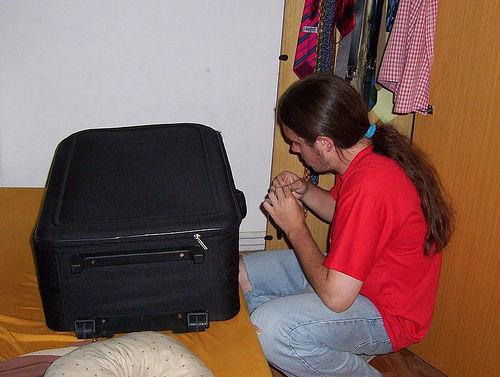Identify the hairstyle of the person in the image. The man has a long ponytail held together with a blue hair band. What is the color of the man's shirt and what type of shirt is it? The man is wearing a red short sleeve shirt. What is the color and type of the object on the man's head? There is a light blue hair band around the man's ponytail. What is the man doing in the image and describe his overall appearance. The man is squatting down, he has long hair tied in a ponytail, is wearing a red shirt and light blue jeans with a rip on the knee. Describe the condition of the man's jeans and what color they are. The man is wearing light blue jeans with a rip at the right knee. Describe any accessories or additional objects present in the image. There are ties hanging up, a black belt, and a metal pin sticking into the suitcase. What type of furniture is the suitcase placed on and what is it made of? The suitcase is on a wooden table. Identify any clothing items hanging in the background. There is a red and white shirt and a red and black necktie hanging on the wall. How many wheels can be seen on the suitcase and what color are they? There are two visible black wheels on the suitcase. What is the color and material of the zipper on the suitcase? The zipper is silver and made of metal. What kind of pants does the man have on? Light colored blue jeans with a hole at the right knee What color is the man's hair? Brown Is the door open or closed? Open Which of these captions describes an object in the image? a) A purple umbrella b) A black suitcase c) A green backpack A black suitcase What is the man in the image wearing in his hair? A blue hair band What kind of table is beneath the suitcase? A wooden table What is the man wearing on his upper body? A red shirt Describe the man's posture in the image. The man is squatting down or kneeling on the floor. Detail the appearance of the suitcase in the image. The suitcase is large, black, and has two wheels, a black handle, and a small metal zipper. Is there any hole in the man's jeans? Yes, there is a hole at his right knee. What is the color of the hair band? Blue What is the color of the suitcase zipper? Silver Where is the suitcase located? On the table What type of shirt is the man wearing? A red short sleeve shirt What material is the table made of? Wood Describe the man's hair in the image. The man has long brown hair and wears it in a ponytail secured by a blue hair band. What is hanging on the door in the image? Ties What color is the suitcase in the image? Black 